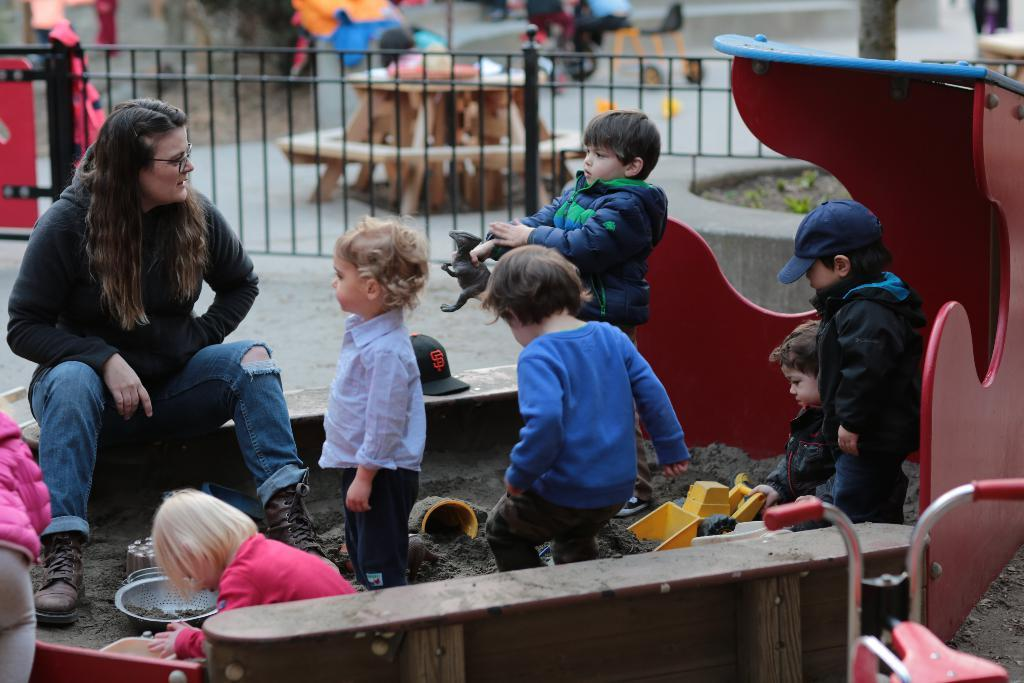What is the lady doing in the image? The lady is sitting on the path in the image. What are the kids doing in the image? The kids are playing with mud in the image. What can be seen in the background of the image? There is a fencing visible in the image. Can you describe any other objects or elements in the scene? There are other unspecified objects or elements around the scene. How many bikes are parked next to the lady in the image? There is no mention of bikes in the image; the lady is sitting on the path, and the kids are playing with mud. 